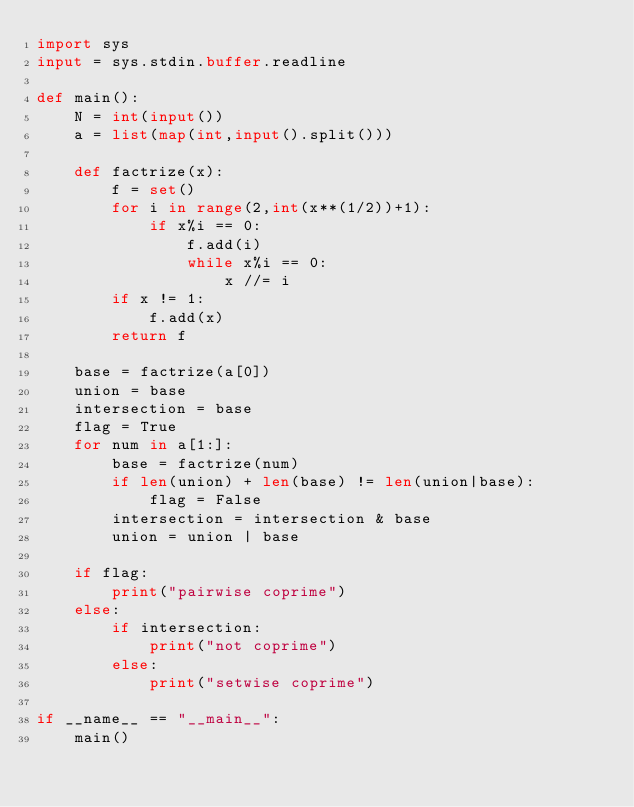Convert code to text. <code><loc_0><loc_0><loc_500><loc_500><_Python_>import sys
input = sys.stdin.buffer.readline

def main():
    N = int(input())
    a = list(map(int,input().split()))
    
    def factrize(x):
        f = set()
        for i in range(2,int(x**(1/2))+1):
            if x%i == 0:
                f.add(i)
                while x%i == 0:
                    x //= i
        if x != 1:
            f.add(x)
        return f
    
    base = factrize(a[0])
    union = base
    intersection = base
    flag = True
    for num in a[1:]:
        base = factrize(num)
        if len(union) + len(base) != len(union|base):
            flag = False
        intersection = intersection & base
        union = union | base
    
    if flag:
        print("pairwise coprime")
    else:
        if intersection:
            print("not coprime")
        else:
            print("setwise coprime")

if __name__ == "__main__":
    main()
</code> 